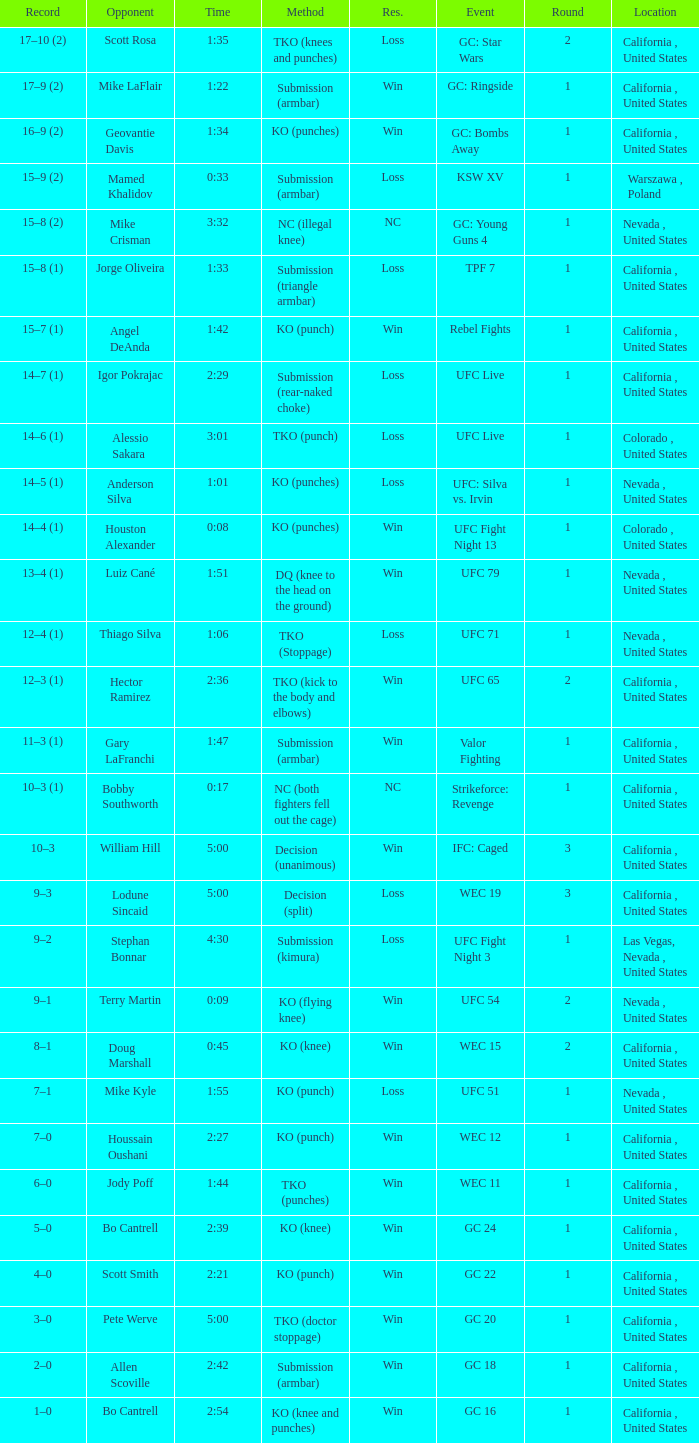What was the method when the time was 1:01? KO (punches). 